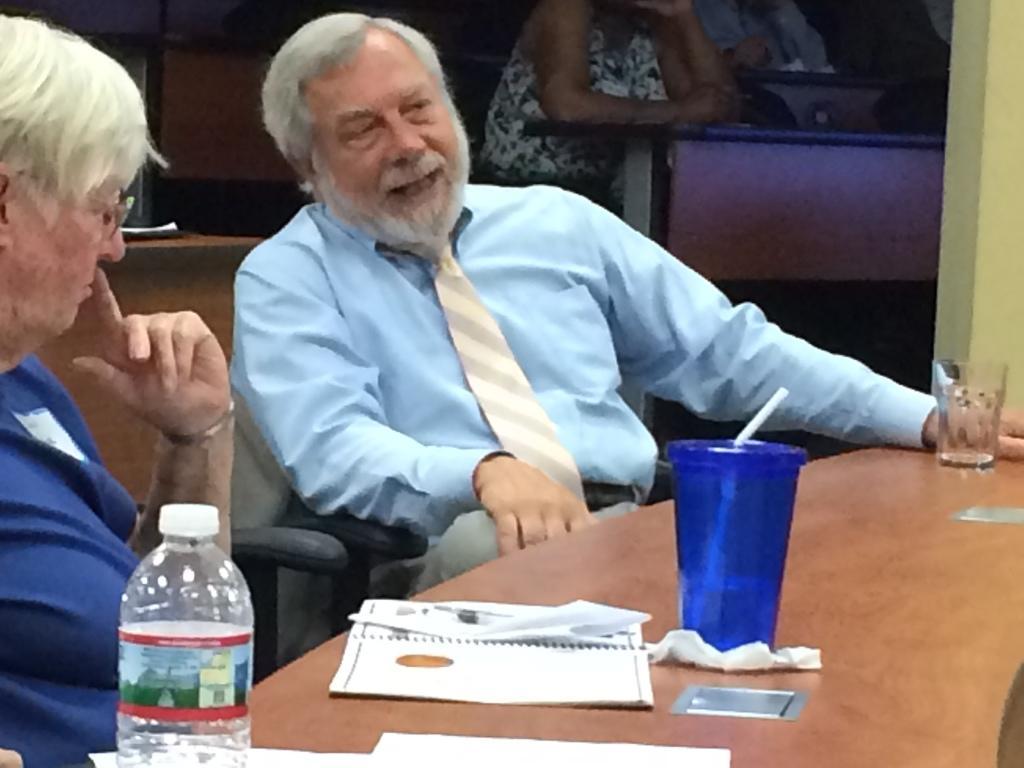Could you give a brief overview of what you see in this image? In the picture we can see a man sitting on the chair just beside to him there is another person sitting in a chair near the table. On the table we can find bottle, a blue glass with straw and another glass. And we can also see some papers and tissue, in the background we can see some persons are sitting on the near the desk. 